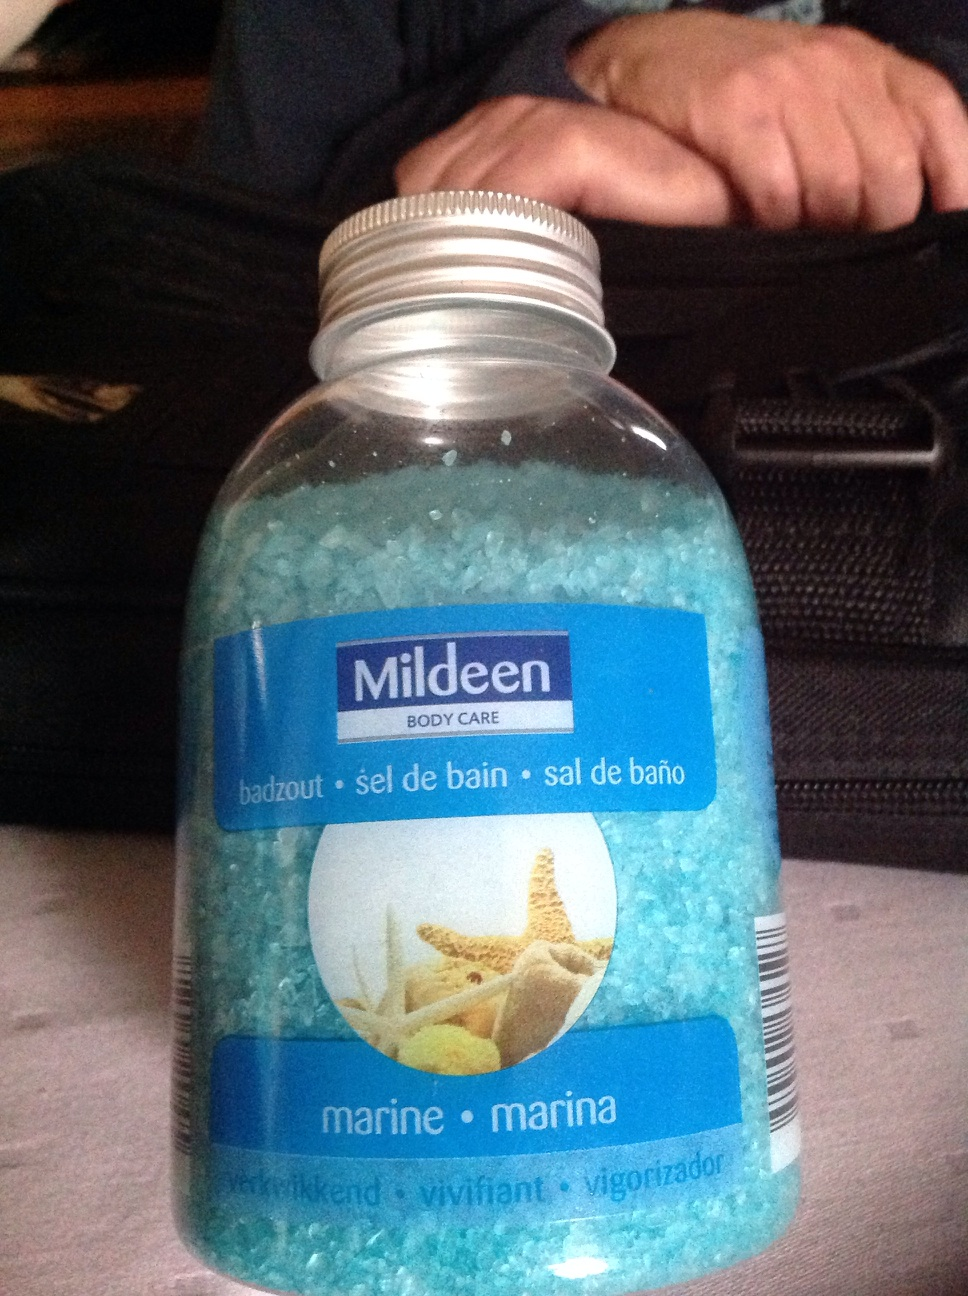What's this? from Vizwiz bath salt 